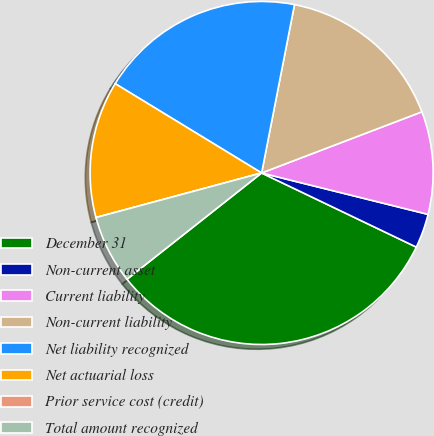Convert chart to OTSL. <chart><loc_0><loc_0><loc_500><loc_500><pie_chart><fcel>December 31<fcel>Non-current asset<fcel>Current liability<fcel>Non-current liability<fcel>Net liability recognized<fcel>Net actuarial loss<fcel>Prior service cost (credit)<fcel>Total amount recognized<nl><fcel>32.25%<fcel>3.23%<fcel>9.68%<fcel>16.13%<fcel>19.35%<fcel>12.9%<fcel>0.0%<fcel>6.45%<nl></chart> 